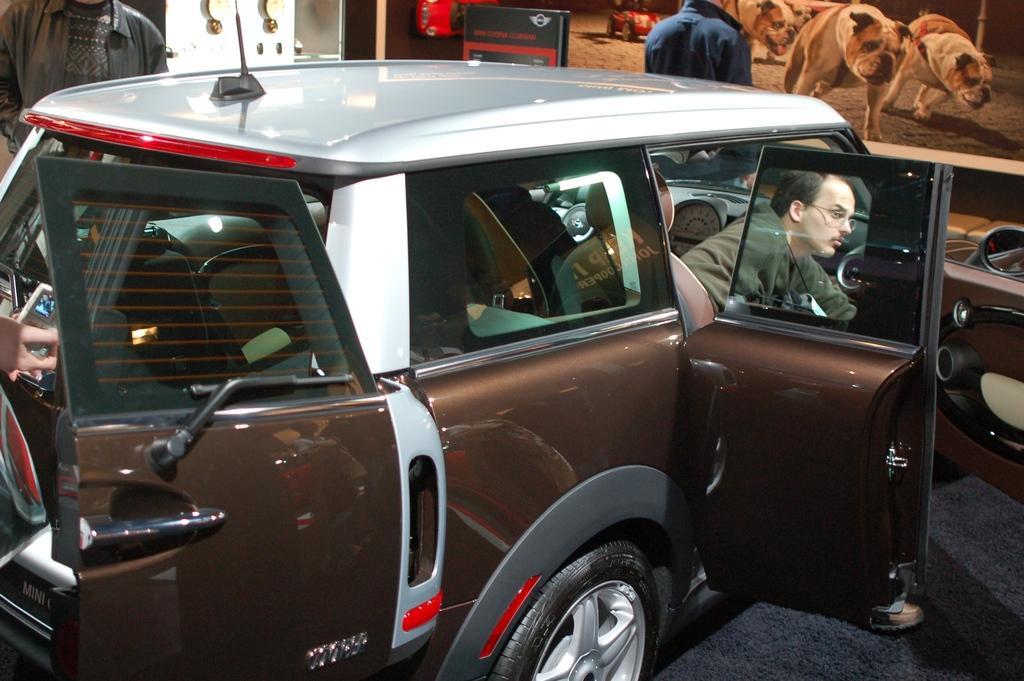What is the main subject of the image? There is a vehicle in the image. Who is inside the vehicle? There is a person inside the vehicle. What can be seen in the background of the image? There are two people standing in the background, a door, a banner, and a screen. What is the condition of the person's chin in the image? There is no information about the person's chin in the image, so it cannot be determined. 